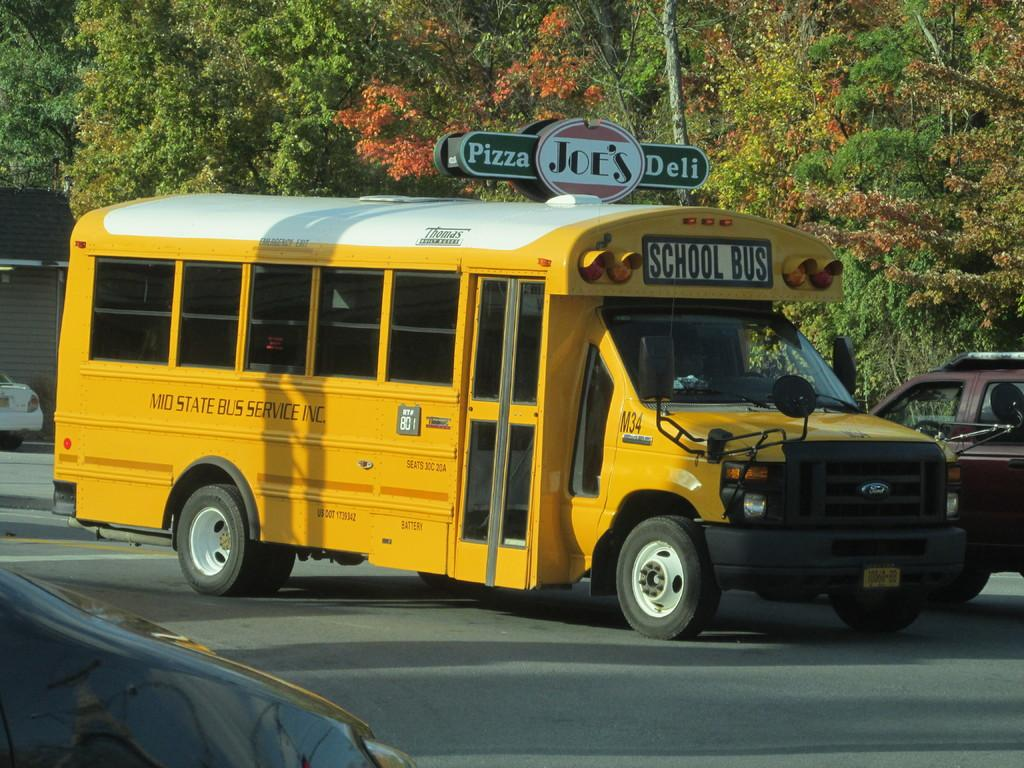Provide a one-sentence caption for the provided image. A short yellow school bus drives down the road passing a pizza shop. 